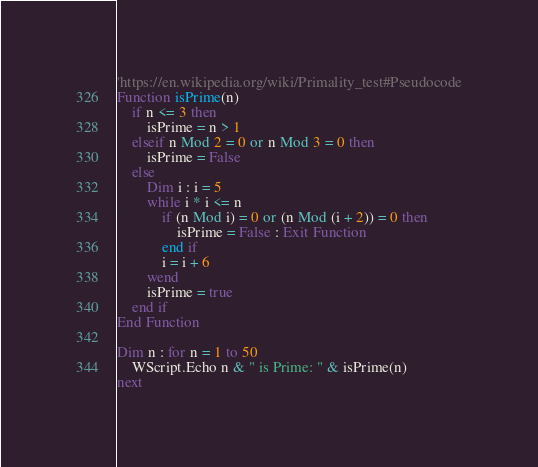Convert code to text. <code><loc_0><loc_0><loc_500><loc_500><_VisualBasic_>'https://en.wikipedia.org/wiki/Primality_test#Pseudocode
Function isPrime(n)
	if n <= 3 then
		isPrime = n > 1
	elseif n Mod 2 = 0 or n Mod 3 = 0 then
		isPrime = False
	else
		Dim i : i = 5
		while i * i <= n
			if (n Mod i) = 0 or (n Mod (i + 2)) = 0 then
				isPrime = False : Exit Function
			end if
			i = i + 6
		wend
		isPrime = true
	end if
End Function

Dim n : for n = 1 to 50
	WScript.Echo n & " is Prime: " & isPrime(n)
next
</code> 